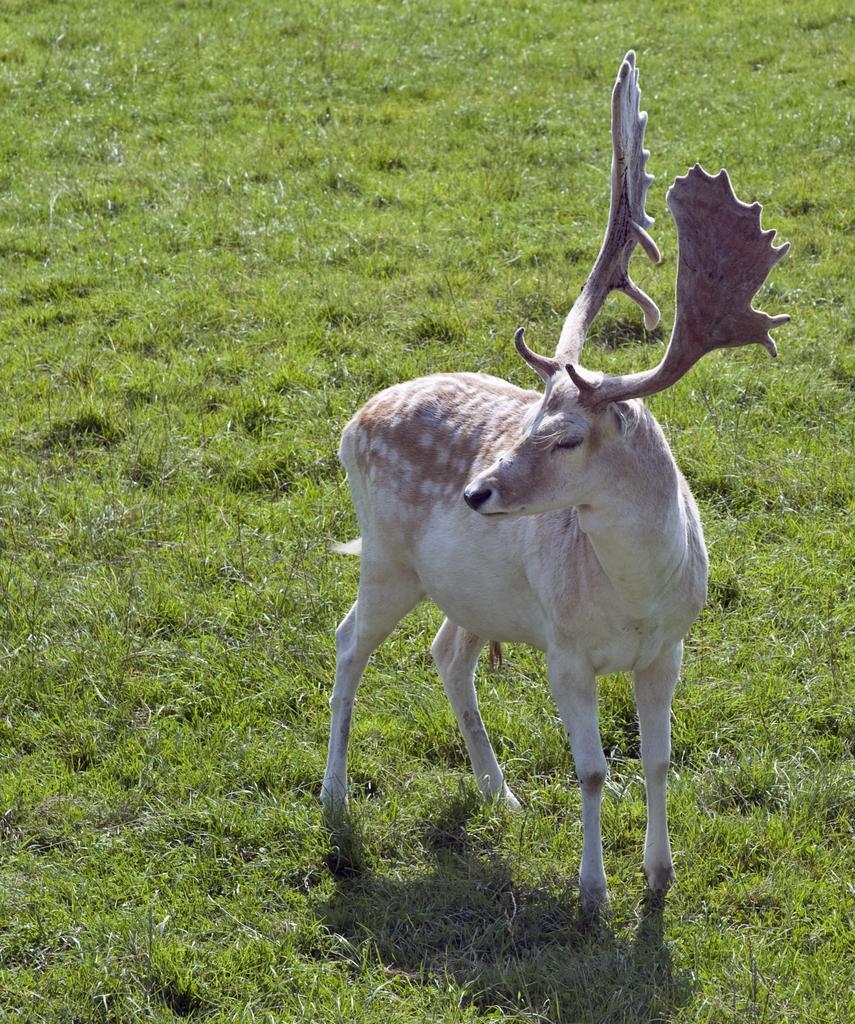In one or two sentences, can you explain what this image depicts? In this picture there is a deer. Here we can see grass. 